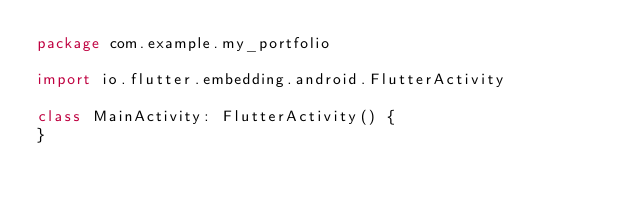Convert code to text. <code><loc_0><loc_0><loc_500><loc_500><_Kotlin_>package com.example.my_portfolio

import io.flutter.embedding.android.FlutterActivity

class MainActivity: FlutterActivity() {
}
</code> 